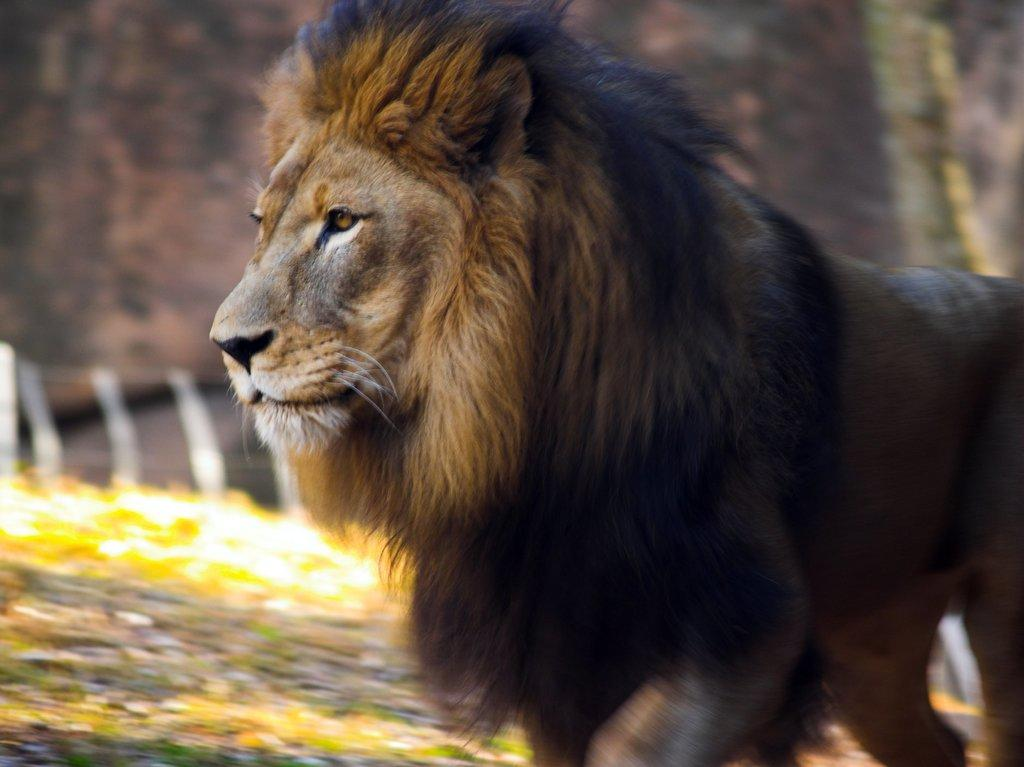What animal is in the image? There is a lion in the image. What is the lion doing in the image? The lion is walking. What type of square can be seen in the image? There is no square present in the image. What kind of cart is being pulled by the lion in the image? There is no cart or any indication of the lion pulling anything in the image. 